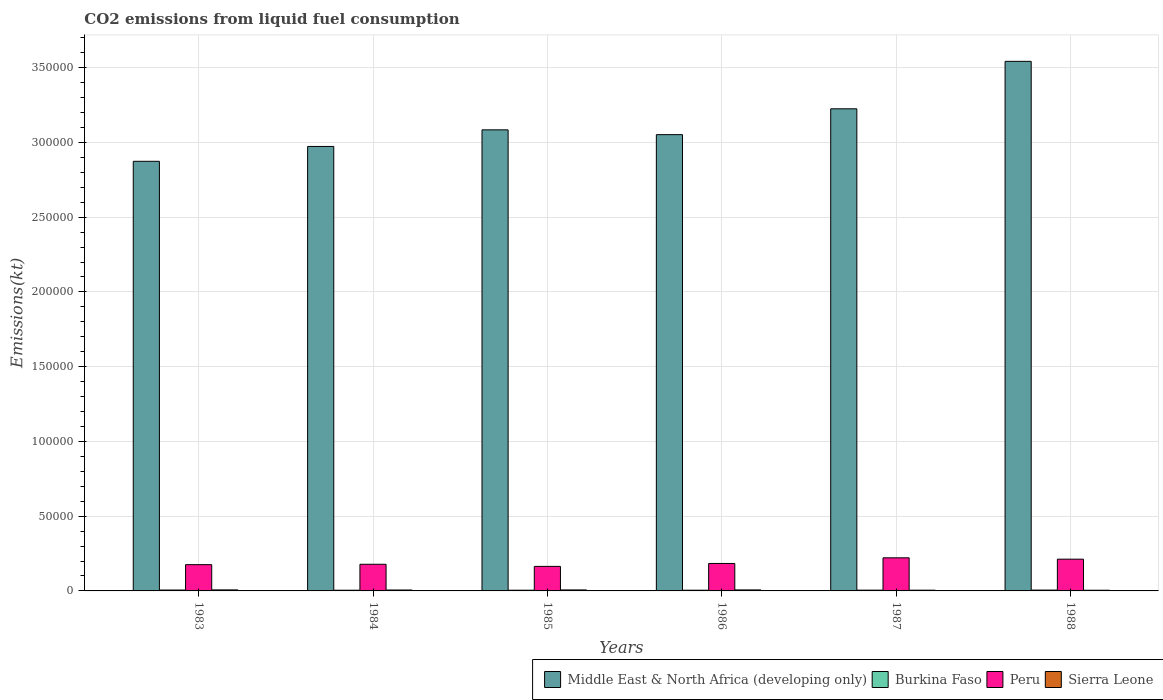Are the number of bars per tick equal to the number of legend labels?
Your answer should be compact. Yes. How many bars are there on the 3rd tick from the left?
Provide a short and direct response. 4. How many bars are there on the 1st tick from the right?
Ensure brevity in your answer.  4. In how many cases, is the number of bars for a given year not equal to the number of legend labels?
Keep it short and to the point. 0. What is the amount of CO2 emitted in Sierra Leone in 1985?
Make the answer very short. 663.73. Across all years, what is the maximum amount of CO2 emitted in Middle East & North Africa (developing only)?
Make the answer very short. 3.54e+05. Across all years, what is the minimum amount of CO2 emitted in Peru?
Your answer should be compact. 1.64e+04. What is the total amount of CO2 emitted in Sierra Leone in the graph?
Keep it short and to the point. 3600.99. What is the difference between the amount of CO2 emitted in Burkina Faso in 1985 and that in 1988?
Offer a very short reply. -77.01. What is the difference between the amount of CO2 emitted in Peru in 1988 and the amount of CO2 emitted in Middle East & North Africa (developing only) in 1983?
Provide a short and direct response. -2.66e+05. What is the average amount of CO2 emitted in Sierra Leone per year?
Give a very brief answer. 600.17. In the year 1985, what is the difference between the amount of CO2 emitted in Burkina Faso and amount of CO2 emitted in Middle East & North Africa (developing only)?
Ensure brevity in your answer.  -3.08e+05. What is the ratio of the amount of CO2 emitted in Sierra Leone in 1983 to that in 1985?
Provide a succinct answer. 1.04. Is the amount of CO2 emitted in Peru in 1983 less than that in 1984?
Keep it short and to the point. Yes. Is the difference between the amount of CO2 emitted in Burkina Faso in 1984 and 1987 greater than the difference between the amount of CO2 emitted in Middle East & North Africa (developing only) in 1984 and 1987?
Provide a succinct answer. Yes. What is the difference between the highest and the second highest amount of CO2 emitted in Burkina Faso?
Provide a short and direct response. 40.34. What is the difference between the highest and the lowest amount of CO2 emitted in Peru?
Offer a terse response. 5724.19. Is the sum of the amount of CO2 emitted in Middle East & North Africa (developing only) in 1986 and 1988 greater than the maximum amount of CO2 emitted in Sierra Leone across all years?
Your response must be concise. Yes. What does the 2nd bar from the left in 1988 represents?
Give a very brief answer. Burkina Faso. What does the 4th bar from the right in 1985 represents?
Offer a terse response. Middle East & North Africa (developing only). Is it the case that in every year, the sum of the amount of CO2 emitted in Peru and amount of CO2 emitted in Middle East & North Africa (developing only) is greater than the amount of CO2 emitted in Burkina Faso?
Provide a short and direct response. Yes. Are the values on the major ticks of Y-axis written in scientific E-notation?
Your answer should be very brief. No. What is the title of the graph?
Offer a terse response. CO2 emissions from liquid fuel consumption. Does "St. Vincent and the Grenadines" appear as one of the legend labels in the graph?
Offer a terse response. No. What is the label or title of the X-axis?
Your response must be concise. Years. What is the label or title of the Y-axis?
Provide a short and direct response. Emissions(kt). What is the Emissions(kt) of Middle East & North Africa (developing only) in 1983?
Give a very brief answer. 2.87e+05. What is the Emissions(kt) in Burkina Faso in 1983?
Make the answer very short. 594.05. What is the Emissions(kt) in Peru in 1983?
Provide a succinct answer. 1.76e+04. What is the Emissions(kt) in Sierra Leone in 1983?
Keep it short and to the point. 689.4. What is the Emissions(kt) in Middle East & North Africa (developing only) in 1984?
Keep it short and to the point. 2.97e+05. What is the Emissions(kt) in Burkina Faso in 1984?
Offer a very short reply. 465.71. What is the Emissions(kt) in Peru in 1984?
Keep it short and to the point. 1.78e+04. What is the Emissions(kt) in Sierra Leone in 1984?
Ensure brevity in your answer.  616.06. What is the Emissions(kt) in Middle East & North Africa (developing only) in 1985?
Ensure brevity in your answer.  3.08e+05. What is the Emissions(kt) of Burkina Faso in 1985?
Provide a succinct answer. 476.71. What is the Emissions(kt) of Peru in 1985?
Your answer should be very brief. 1.64e+04. What is the Emissions(kt) of Sierra Leone in 1985?
Make the answer very short. 663.73. What is the Emissions(kt) in Middle East & North Africa (developing only) in 1986?
Ensure brevity in your answer.  3.05e+05. What is the Emissions(kt) in Burkina Faso in 1986?
Offer a terse response. 480.38. What is the Emissions(kt) of Peru in 1986?
Ensure brevity in your answer.  1.84e+04. What is the Emissions(kt) in Sierra Leone in 1986?
Provide a succinct answer. 674.73. What is the Emissions(kt) in Middle East & North Africa (developing only) in 1987?
Keep it short and to the point. 3.22e+05. What is the Emissions(kt) of Burkina Faso in 1987?
Provide a short and direct response. 517.05. What is the Emissions(kt) of Peru in 1987?
Your answer should be compact. 2.21e+04. What is the Emissions(kt) in Sierra Leone in 1987?
Make the answer very short. 498.71. What is the Emissions(kt) in Middle East & North Africa (developing only) in 1988?
Give a very brief answer. 3.54e+05. What is the Emissions(kt) of Burkina Faso in 1988?
Your answer should be compact. 553.72. What is the Emissions(kt) of Peru in 1988?
Make the answer very short. 2.12e+04. What is the Emissions(kt) of Sierra Leone in 1988?
Offer a terse response. 458.38. Across all years, what is the maximum Emissions(kt) in Middle East & North Africa (developing only)?
Your answer should be very brief. 3.54e+05. Across all years, what is the maximum Emissions(kt) in Burkina Faso?
Give a very brief answer. 594.05. Across all years, what is the maximum Emissions(kt) of Peru?
Keep it short and to the point. 2.21e+04. Across all years, what is the maximum Emissions(kt) of Sierra Leone?
Give a very brief answer. 689.4. Across all years, what is the minimum Emissions(kt) of Middle East & North Africa (developing only)?
Your answer should be very brief. 2.87e+05. Across all years, what is the minimum Emissions(kt) of Burkina Faso?
Give a very brief answer. 465.71. Across all years, what is the minimum Emissions(kt) in Peru?
Give a very brief answer. 1.64e+04. Across all years, what is the minimum Emissions(kt) in Sierra Leone?
Your response must be concise. 458.38. What is the total Emissions(kt) of Middle East & North Africa (developing only) in the graph?
Give a very brief answer. 1.88e+06. What is the total Emissions(kt) of Burkina Faso in the graph?
Keep it short and to the point. 3087.61. What is the total Emissions(kt) of Peru in the graph?
Keep it short and to the point. 1.14e+05. What is the total Emissions(kt) of Sierra Leone in the graph?
Give a very brief answer. 3600.99. What is the difference between the Emissions(kt) in Middle East & North Africa (developing only) in 1983 and that in 1984?
Your response must be concise. -9935.62. What is the difference between the Emissions(kt) of Burkina Faso in 1983 and that in 1984?
Your answer should be compact. 128.34. What is the difference between the Emissions(kt) in Peru in 1983 and that in 1984?
Provide a short and direct response. -245.69. What is the difference between the Emissions(kt) in Sierra Leone in 1983 and that in 1984?
Provide a succinct answer. 73.34. What is the difference between the Emissions(kt) of Middle East & North Africa (developing only) in 1983 and that in 1985?
Your response must be concise. -2.10e+04. What is the difference between the Emissions(kt) in Burkina Faso in 1983 and that in 1985?
Offer a terse response. 117.34. What is the difference between the Emissions(kt) of Peru in 1983 and that in 1985?
Ensure brevity in your answer.  1162.44. What is the difference between the Emissions(kt) of Sierra Leone in 1983 and that in 1985?
Offer a terse response. 25.67. What is the difference between the Emissions(kt) in Middle East & North Africa (developing only) in 1983 and that in 1986?
Offer a terse response. -1.78e+04. What is the difference between the Emissions(kt) in Burkina Faso in 1983 and that in 1986?
Offer a terse response. 113.68. What is the difference between the Emissions(kt) in Peru in 1983 and that in 1986?
Your answer should be very brief. -788.4. What is the difference between the Emissions(kt) of Sierra Leone in 1983 and that in 1986?
Ensure brevity in your answer.  14.67. What is the difference between the Emissions(kt) of Middle East & North Africa (developing only) in 1983 and that in 1987?
Keep it short and to the point. -3.51e+04. What is the difference between the Emissions(kt) in Burkina Faso in 1983 and that in 1987?
Make the answer very short. 77.01. What is the difference between the Emissions(kt) in Peru in 1983 and that in 1987?
Provide a succinct answer. -4561.75. What is the difference between the Emissions(kt) of Sierra Leone in 1983 and that in 1987?
Make the answer very short. 190.68. What is the difference between the Emissions(kt) of Middle East & North Africa (developing only) in 1983 and that in 1988?
Offer a terse response. -6.69e+04. What is the difference between the Emissions(kt) of Burkina Faso in 1983 and that in 1988?
Make the answer very short. 40.34. What is the difference between the Emissions(kt) in Peru in 1983 and that in 1988?
Your answer should be very brief. -3663.33. What is the difference between the Emissions(kt) in Sierra Leone in 1983 and that in 1988?
Provide a succinct answer. 231.02. What is the difference between the Emissions(kt) in Middle East & North Africa (developing only) in 1984 and that in 1985?
Your answer should be very brief. -1.11e+04. What is the difference between the Emissions(kt) of Burkina Faso in 1984 and that in 1985?
Make the answer very short. -11. What is the difference between the Emissions(kt) in Peru in 1984 and that in 1985?
Ensure brevity in your answer.  1408.13. What is the difference between the Emissions(kt) in Sierra Leone in 1984 and that in 1985?
Your answer should be compact. -47.67. What is the difference between the Emissions(kt) in Middle East & North Africa (developing only) in 1984 and that in 1986?
Offer a terse response. -7894.91. What is the difference between the Emissions(kt) in Burkina Faso in 1984 and that in 1986?
Provide a short and direct response. -14.67. What is the difference between the Emissions(kt) in Peru in 1984 and that in 1986?
Ensure brevity in your answer.  -542.72. What is the difference between the Emissions(kt) in Sierra Leone in 1984 and that in 1986?
Your answer should be compact. -58.67. What is the difference between the Emissions(kt) in Middle East & North Africa (developing only) in 1984 and that in 1987?
Offer a very short reply. -2.52e+04. What is the difference between the Emissions(kt) in Burkina Faso in 1984 and that in 1987?
Ensure brevity in your answer.  -51.34. What is the difference between the Emissions(kt) in Peru in 1984 and that in 1987?
Make the answer very short. -4316.06. What is the difference between the Emissions(kt) in Sierra Leone in 1984 and that in 1987?
Your answer should be compact. 117.34. What is the difference between the Emissions(kt) of Middle East & North Africa (developing only) in 1984 and that in 1988?
Provide a short and direct response. -5.69e+04. What is the difference between the Emissions(kt) of Burkina Faso in 1984 and that in 1988?
Your answer should be compact. -88.01. What is the difference between the Emissions(kt) of Peru in 1984 and that in 1988?
Make the answer very short. -3417.64. What is the difference between the Emissions(kt) of Sierra Leone in 1984 and that in 1988?
Your response must be concise. 157.68. What is the difference between the Emissions(kt) of Middle East & North Africa (developing only) in 1985 and that in 1986?
Provide a succinct answer. 3207.88. What is the difference between the Emissions(kt) of Burkina Faso in 1985 and that in 1986?
Provide a short and direct response. -3.67. What is the difference between the Emissions(kt) of Peru in 1985 and that in 1986?
Give a very brief answer. -1950.84. What is the difference between the Emissions(kt) of Sierra Leone in 1985 and that in 1986?
Offer a terse response. -11. What is the difference between the Emissions(kt) of Middle East & North Africa (developing only) in 1985 and that in 1987?
Provide a succinct answer. -1.41e+04. What is the difference between the Emissions(kt) of Burkina Faso in 1985 and that in 1987?
Give a very brief answer. -40.34. What is the difference between the Emissions(kt) of Peru in 1985 and that in 1987?
Make the answer very short. -5724.19. What is the difference between the Emissions(kt) in Sierra Leone in 1985 and that in 1987?
Your answer should be very brief. 165.01. What is the difference between the Emissions(kt) in Middle East & North Africa (developing only) in 1985 and that in 1988?
Offer a very short reply. -4.58e+04. What is the difference between the Emissions(kt) in Burkina Faso in 1985 and that in 1988?
Ensure brevity in your answer.  -77.01. What is the difference between the Emissions(kt) of Peru in 1985 and that in 1988?
Your answer should be very brief. -4825.77. What is the difference between the Emissions(kt) in Sierra Leone in 1985 and that in 1988?
Offer a very short reply. 205.35. What is the difference between the Emissions(kt) of Middle East & North Africa (developing only) in 1986 and that in 1987?
Ensure brevity in your answer.  -1.73e+04. What is the difference between the Emissions(kt) in Burkina Faso in 1986 and that in 1987?
Your answer should be compact. -36.67. What is the difference between the Emissions(kt) of Peru in 1986 and that in 1987?
Offer a very short reply. -3773.34. What is the difference between the Emissions(kt) of Sierra Leone in 1986 and that in 1987?
Ensure brevity in your answer.  176.02. What is the difference between the Emissions(kt) of Middle East & North Africa (developing only) in 1986 and that in 1988?
Make the answer very short. -4.90e+04. What is the difference between the Emissions(kt) of Burkina Faso in 1986 and that in 1988?
Offer a terse response. -73.34. What is the difference between the Emissions(kt) of Peru in 1986 and that in 1988?
Your answer should be compact. -2874.93. What is the difference between the Emissions(kt) of Sierra Leone in 1986 and that in 1988?
Keep it short and to the point. 216.35. What is the difference between the Emissions(kt) of Middle East & North Africa (developing only) in 1987 and that in 1988?
Make the answer very short. -3.17e+04. What is the difference between the Emissions(kt) in Burkina Faso in 1987 and that in 1988?
Your response must be concise. -36.67. What is the difference between the Emissions(kt) of Peru in 1987 and that in 1988?
Make the answer very short. 898.41. What is the difference between the Emissions(kt) of Sierra Leone in 1987 and that in 1988?
Offer a terse response. 40.34. What is the difference between the Emissions(kt) in Middle East & North Africa (developing only) in 1983 and the Emissions(kt) in Burkina Faso in 1984?
Your response must be concise. 2.87e+05. What is the difference between the Emissions(kt) of Middle East & North Africa (developing only) in 1983 and the Emissions(kt) of Peru in 1984?
Provide a succinct answer. 2.70e+05. What is the difference between the Emissions(kt) of Middle East & North Africa (developing only) in 1983 and the Emissions(kt) of Sierra Leone in 1984?
Make the answer very short. 2.87e+05. What is the difference between the Emissions(kt) in Burkina Faso in 1983 and the Emissions(kt) in Peru in 1984?
Provide a succinct answer. -1.72e+04. What is the difference between the Emissions(kt) of Burkina Faso in 1983 and the Emissions(kt) of Sierra Leone in 1984?
Your answer should be compact. -22. What is the difference between the Emissions(kt) of Peru in 1983 and the Emissions(kt) of Sierra Leone in 1984?
Provide a succinct answer. 1.70e+04. What is the difference between the Emissions(kt) of Middle East & North Africa (developing only) in 1983 and the Emissions(kt) of Burkina Faso in 1985?
Offer a very short reply. 2.87e+05. What is the difference between the Emissions(kt) in Middle East & North Africa (developing only) in 1983 and the Emissions(kt) in Peru in 1985?
Your answer should be very brief. 2.71e+05. What is the difference between the Emissions(kt) in Middle East & North Africa (developing only) in 1983 and the Emissions(kt) in Sierra Leone in 1985?
Keep it short and to the point. 2.87e+05. What is the difference between the Emissions(kt) of Burkina Faso in 1983 and the Emissions(kt) of Peru in 1985?
Provide a succinct answer. -1.58e+04. What is the difference between the Emissions(kt) of Burkina Faso in 1983 and the Emissions(kt) of Sierra Leone in 1985?
Your response must be concise. -69.67. What is the difference between the Emissions(kt) in Peru in 1983 and the Emissions(kt) in Sierra Leone in 1985?
Provide a short and direct response. 1.69e+04. What is the difference between the Emissions(kt) of Middle East & North Africa (developing only) in 1983 and the Emissions(kt) of Burkina Faso in 1986?
Provide a short and direct response. 2.87e+05. What is the difference between the Emissions(kt) in Middle East & North Africa (developing only) in 1983 and the Emissions(kt) in Peru in 1986?
Provide a succinct answer. 2.69e+05. What is the difference between the Emissions(kt) of Middle East & North Africa (developing only) in 1983 and the Emissions(kt) of Sierra Leone in 1986?
Provide a short and direct response. 2.87e+05. What is the difference between the Emissions(kt) of Burkina Faso in 1983 and the Emissions(kt) of Peru in 1986?
Ensure brevity in your answer.  -1.78e+04. What is the difference between the Emissions(kt) of Burkina Faso in 1983 and the Emissions(kt) of Sierra Leone in 1986?
Your response must be concise. -80.67. What is the difference between the Emissions(kt) in Peru in 1983 and the Emissions(kt) in Sierra Leone in 1986?
Your answer should be compact. 1.69e+04. What is the difference between the Emissions(kt) in Middle East & North Africa (developing only) in 1983 and the Emissions(kt) in Burkina Faso in 1987?
Offer a terse response. 2.87e+05. What is the difference between the Emissions(kt) of Middle East & North Africa (developing only) in 1983 and the Emissions(kt) of Peru in 1987?
Make the answer very short. 2.65e+05. What is the difference between the Emissions(kt) in Middle East & North Africa (developing only) in 1983 and the Emissions(kt) in Sierra Leone in 1987?
Give a very brief answer. 2.87e+05. What is the difference between the Emissions(kt) in Burkina Faso in 1983 and the Emissions(kt) in Peru in 1987?
Ensure brevity in your answer.  -2.15e+04. What is the difference between the Emissions(kt) in Burkina Faso in 1983 and the Emissions(kt) in Sierra Leone in 1987?
Keep it short and to the point. 95.34. What is the difference between the Emissions(kt) of Peru in 1983 and the Emissions(kt) of Sierra Leone in 1987?
Offer a very short reply. 1.71e+04. What is the difference between the Emissions(kt) in Middle East & North Africa (developing only) in 1983 and the Emissions(kt) in Burkina Faso in 1988?
Offer a terse response. 2.87e+05. What is the difference between the Emissions(kt) in Middle East & North Africa (developing only) in 1983 and the Emissions(kt) in Peru in 1988?
Provide a succinct answer. 2.66e+05. What is the difference between the Emissions(kt) in Middle East & North Africa (developing only) in 1983 and the Emissions(kt) in Sierra Leone in 1988?
Offer a very short reply. 2.87e+05. What is the difference between the Emissions(kt) in Burkina Faso in 1983 and the Emissions(kt) in Peru in 1988?
Provide a short and direct response. -2.06e+04. What is the difference between the Emissions(kt) of Burkina Faso in 1983 and the Emissions(kt) of Sierra Leone in 1988?
Offer a very short reply. 135.68. What is the difference between the Emissions(kt) of Peru in 1983 and the Emissions(kt) of Sierra Leone in 1988?
Provide a succinct answer. 1.71e+04. What is the difference between the Emissions(kt) in Middle East & North Africa (developing only) in 1984 and the Emissions(kt) in Burkina Faso in 1985?
Give a very brief answer. 2.97e+05. What is the difference between the Emissions(kt) of Middle East & North Africa (developing only) in 1984 and the Emissions(kt) of Peru in 1985?
Provide a short and direct response. 2.81e+05. What is the difference between the Emissions(kt) in Middle East & North Africa (developing only) in 1984 and the Emissions(kt) in Sierra Leone in 1985?
Your answer should be very brief. 2.97e+05. What is the difference between the Emissions(kt) of Burkina Faso in 1984 and the Emissions(kt) of Peru in 1985?
Provide a succinct answer. -1.59e+04. What is the difference between the Emissions(kt) of Burkina Faso in 1984 and the Emissions(kt) of Sierra Leone in 1985?
Give a very brief answer. -198.02. What is the difference between the Emissions(kt) in Peru in 1984 and the Emissions(kt) in Sierra Leone in 1985?
Ensure brevity in your answer.  1.72e+04. What is the difference between the Emissions(kt) in Middle East & North Africa (developing only) in 1984 and the Emissions(kt) in Burkina Faso in 1986?
Provide a succinct answer. 2.97e+05. What is the difference between the Emissions(kt) in Middle East & North Africa (developing only) in 1984 and the Emissions(kt) in Peru in 1986?
Provide a succinct answer. 2.79e+05. What is the difference between the Emissions(kt) of Middle East & North Africa (developing only) in 1984 and the Emissions(kt) of Sierra Leone in 1986?
Provide a short and direct response. 2.97e+05. What is the difference between the Emissions(kt) of Burkina Faso in 1984 and the Emissions(kt) of Peru in 1986?
Offer a very short reply. -1.79e+04. What is the difference between the Emissions(kt) in Burkina Faso in 1984 and the Emissions(kt) in Sierra Leone in 1986?
Provide a short and direct response. -209.02. What is the difference between the Emissions(kt) in Peru in 1984 and the Emissions(kt) in Sierra Leone in 1986?
Offer a terse response. 1.71e+04. What is the difference between the Emissions(kt) of Middle East & North Africa (developing only) in 1984 and the Emissions(kt) of Burkina Faso in 1987?
Make the answer very short. 2.97e+05. What is the difference between the Emissions(kt) of Middle East & North Africa (developing only) in 1984 and the Emissions(kt) of Peru in 1987?
Make the answer very short. 2.75e+05. What is the difference between the Emissions(kt) of Middle East & North Africa (developing only) in 1984 and the Emissions(kt) of Sierra Leone in 1987?
Offer a very short reply. 2.97e+05. What is the difference between the Emissions(kt) of Burkina Faso in 1984 and the Emissions(kt) of Peru in 1987?
Your answer should be compact. -2.17e+04. What is the difference between the Emissions(kt) of Burkina Faso in 1984 and the Emissions(kt) of Sierra Leone in 1987?
Offer a terse response. -33. What is the difference between the Emissions(kt) of Peru in 1984 and the Emissions(kt) of Sierra Leone in 1987?
Provide a succinct answer. 1.73e+04. What is the difference between the Emissions(kt) of Middle East & North Africa (developing only) in 1984 and the Emissions(kt) of Burkina Faso in 1988?
Offer a terse response. 2.97e+05. What is the difference between the Emissions(kt) of Middle East & North Africa (developing only) in 1984 and the Emissions(kt) of Peru in 1988?
Your answer should be very brief. 2.76e+05. What is the difference between the Emissions(kt) in Middle East & North Africa (developing only) in 1984 and the Emissions(kt) in Sierra Leone in 1988?
Your answer should be compact. 2.97e+05. What is the difference between the Emissions(kt) of Burkina Faso in 1984 and the Emissions(kt) of Peru in 1988?
Make the answer very short. -2.08e+04. What is the difference between the Emissions(kt) in Burkina Faso in 1984 and the Emissions(kt) in Sierra Leone in 1988?
Provide a succinct answer. 7.33. What is the difference between the Emissions(kt) of Peru in 1984 and the Emissions(kt) of Sierra Leone in 1988?
Give a very brief answer. 1.74e+04. What is the difference between the Emissions(kt) of Middle East & North Africa (developing only) in 1985 and the Emissions(kt) of Burkina Faso in 1986?
Keep it short and to the point. 3.08e+05. What is the difference between the Emissions(kt) of Middle East & North Africa (developing only) in 1985 and the Emissions(kt) of Peru in 1986?
Your answer should be very brief. 2.90e+05. What is the difference between the Emissions(kt) of Middle East & North Africa (developing only) in 1985 and the Emissions(kt) of Sierra Leone in 1986?
Your answer should be compact. 3.08e+05. What is the difference between the Emissions(kt) in Burkina Faso in 1985 and the Emissions(kt) in Peru in 1986?
Ensure brevity in your answer.  -1.79e+04. What is the difference between the Emissions(kt) in Burkina Faso in 1985 and the Emissions(kt) in Sierra Leone in 1986?
Ensure brevity in your answer.  -198.02. What is the difference between the Emissions(kt) of Peru in 1985 and the Emissions(kt) of Sierra Leone in 1986?
Your answer should be compact. 1.57e+04. What is the difference between the Emissions(kt) in Middle East & North Africa (developing only) in 1985 and the Emissions(kt) in Burkina Faso in 1987?
Your answer should be very brief. 3.08e+05. What is the difference between the Emissions(kt) in Middle East & North Africa (developing only) in 1985 and the Emissions(kt) in Peru in 1987?
Provide a short and direct response. 2.86e+05. What is the difference between the Emissions(kt) of Middle East & North Africa (developing only) in 1985 and the Emissions(kt) of Sierra Leone in 1987?
Keep it short and to the point. 3.08e+05. What is the difference between the Emissions(kt) in Burkina Faso in 1985 and the Emissions(kt) in Peru in 1987?
Provide a succinct answer. -2.17e+04. What is the difference between the Emissions(kt) of Burkina Faso in 1985 and the Emissions(kt) of Sierra Leone in 1987?
Provide a succinct answer. -22. What is the difference between the Emissions(kt) in Peru in 1985 and the Emissions(kt) in Sierra Leone in 1987?
Offer a terse response. 1.59e+04. What is the difference between the Emissions(kt) of Middle East & North Africa (developing only) in 1985 and the Emissions(kt) of Burkina Faso in 1988?
Make the answer very short. 3.08e+05. What is the difference between the Emissions(kt) in Middle East & North Africa (developing only) in 1985 and the Emissions(kt) in Peru in 1988?
Ensure brevity in your answer.  2.87e+05. What is the difference between the Emissions(kt) of Middle East & North Africa (developing only) in 1985 and the Emissions(kt) of Sierra Leone in 1988?
Give a very brief answer. 3.08e+05. What is the difference between the Emissions(kt) of Burkina Faso in 1985 and the Emissions(kt) of Peru in 1988?
Offer a very short reply. -2.08e+04. What is the difference between the Emissions(kt) of Burkina Faso in 1985 and the Emissions(kt) of Sierra Leone in 1988?
Ensure brevity in your answer.  18.34. What is the difference between the Emissions(kt) in Peru in 1985 and the Emissions(kt) in Sierra Leone in 1988?
Your response must be concise. 1.60e+04. What is the difference between the Emissions(kt) of Middle East & North Africa (developing only) in 1986 and the Emissions(kt) of Burkina Faso in 1987?
Offer a very short reply. 3.05e+05. What is the difference between the Emissions(kt) in Middle East & North Africa (developing only) in 1986 and the Emissions(kt) in Peru in 1987?
Ensure brevity in your answer.  2.83e+05. What is the difference between the Emissions(kt) of Middle East & North Africa (developing only) in 1986 and the Emissions(kt) of Sierra Leone in 1987?
Give a very brief answer. 3.05e+05. What is the difference between the Emissions(kt) of Burkina Faso in 1986 and the Emissions(kt) of Peru in 1987?
Your response must be concise. -2.17e+04. What is the difference between the Emissions(kt) of Burkina Faso in 1986 and the Emissions(kt) of Sierra Leone in 1987?
Offer a terse response. -18.34. What is the difference between the Emissions(kt) in Peru in 1986 and the Emissions(kt) in Sierra Leone in 1987?
Your answer should be compact. 1.79e+04. What is the difference between the Emissions(kt) of Middle East & North Africa (developing only) in 1986 and the Emissions(kt) of Burkina Faso in 1988?
Provide a short and direct response. 3.05e+05. What is the difference between the Emissions(kt) in Middle East & North Africa (developing only) in 1986 and the Emissions(kt) in Peru in 1988?
Your response must be concise. 2.84e+05. What is the difference between the Emissions(kt) of Middle East & North Africa (developing only) in 1986 and the Emissions(kt) of Sierra Leone in 1988?
Offer a very short reply. 3.05e+05. What is the difference between the Emissions(kt) in Burkina Faso in 1986 and the Emissions(kt) in Peru in 1988?
Provide a succinct answer. -2.08e+04. What is the difference between the Emissions(kt) of Burkina Faso in 1986 and the Emissions(kt) of Sierra Leone in 1988?
Provide a short and direct response. 22. What is the difference between the Emissions(kt) of Peru in 1986 and the Emissions(kt) of Sierra Leone in 1988?
Ensure brevity in your answer.  1.79e+04. What is the difference between the Emissions(kt) in Middle East & North Africa (developing only) in 1987 and the Emissions(kt) in Burkina Faso in 1988?
Offer a very short reply. 3.22e+05. What is the difference between the Emissions(kt) of Middle East & North Africa (developing only) in 1987 and the Emissions(kt) of Peru in 1988?
Offer a terse response. 3.01e+05. What is the difference between the Emissions(kt) in Middle East & North Africa (developing only) in 1987 and the Emissions(kt) in Sierra Leone in 1988?
Give a very brief answer. 3.22e+05. What is the difference between the Emissions(kt) in Burkina Faso in 1987 and the Emissions(kt) in Peru in 1988?
Make the answer very short. -2.07e+04. What is the difference between the Emissions(kt) of Burkina Faso in 1987 and the Emissions(kt) of Sierra Leone in 1988?
Provide a short and direct response. 58.67. What is the difference between the Emissions(kt) of Peru in 1987 and the Emissions(kt) of Sierra Leone in 1988?
Your response must be concise. 2.17e+04. What is the average Emissions(kt) of Middle East & North Africa (developing only) per year?
Provide a succinct answer. 3.13e+05. What is the average Emissions(kt) in Burkina Faso per year?
Give a very brief answer. 514.6. What is the average Emissions(kt) of Peru per year?
Your response must be concise. 1.89e+04. What is the average Emissions(kt) of Sierra Leone per year?
Provide a short and direct response. 600.17. In the year 1983, what is the difference between the Emissions(kt) in Middle East & North Africa (developing only) and Emissions(kt) in Burkina Faso?
Keep it short and to the point. 2.87e+05. In the year 1983, what is the difference between the Emissions(kt) of Middle East & North Africa (developing only) and Emissions(kt) of Peru?
Make the answer very short. 2.70e+05. In the year 1983, what is the difference between the Emissions(kt) in Middle East & North Africa (developing only) and Emissions(kt) in Sierra Leone?
Provide a short and direct response. 2.87e+05. In the year 1983, what is the difference between the Emissions(kt) in Burkina Faso and Emissions(kt) in Peru?
Provide a succinct answer. -1.70e+04. In the year 1983, what is the difference between the Emissions(kt) in Burkina Faso and Emissions(kt) in Sierra Leone?
Provide a succinct answer. -95.34. In the year 1983, what is the difference between the Emissions(kt) of Peru and Emissions(kt) of Sierra Leone?
Your answer should be very brief. 1.69e+04. In the year 1984, what is the difference between the Emissions(kt) of Middle East & North Africa (developing only) and Emissions(kt) of Burkina Faso?
Provide a short and direct response. 2.97e+05. In the year 1984, what is the difference between the Emissions(kt) in Middle East & North Africa (developing only) and Emissions(kt) in Peru?
Ensure brevity in your answer.  2.79e+05. In the year 1984, what is the difference between the Emissions(kt) in Middle East & North Africa (developing only) and Emissions(kt) in Sierra Leone?
Ensure brevity in your answer.  2.97e+05. In the year 1984, what is the difference between the Emissions(kt) in Burkina Faso and Emissions(kt) in Peru?
Your answer should be very brief. -1.74e+04. In the year 1984, what is the difference between the Emissions(kt) of Burkina Faso and Emissions(kt) of Sierra Leone?
Provide a short and direct response. -150.35. In the year 1984, what is the difference between the Emissions(kt) of Peru and Emissions(kt) of Sierra Leone?
Your answer should be compact. 1.72e+04. In the year 1985, what is the difference between the Emissions(kt) in Middle East & North Africa (developing only) and Emissions(kt) in Burkina Faso?
Give a very brief answer. 3.08e+05. In the year 1985, what is the difference between the Emissions(kt) in Middle East & North Africa (developing only) and Emissions(kt) in Peru?
Ensure brevity in your answer.  2.92e+05. In the year 1985, what is the difference between the Emissions(kt) of Middle East & North Africa (developing only) and Emissions(kt) of Sierra Leone?
Ensure brevity in your answer.  3.08e+05. In the year 1985, what is the difference between the Emissions(kt) of Burkina Faso and Emissions(kt) of Peru?
Your answer should be compact. -1.59e+04. In the year 1985, what is the difference between the Emissions(kt) of Burkina Faso and Emissions(kt) of Sierra Leone?
Provide a short and direct response. -187.02. In the year 1985, what is the difference between the Emissions(kt) of Peru and Emissions(kt) of Sierra Leone?
Your answer should be very brief. 1.57e+04. In the year 1986, what is the difference between the Emissions(kt) of Middle East & North Africa (developing only) and Emissions(kt) of Burkina Faso?
Make the answer very short. 3.05e+05. In the year 1986, what is the difference between the Emissions(kt) of Middle East & North Africa (developing only) and Emissions(kt) of Peru?
Offer a very short reply. 2.87e+05. In the year 1986, what is the difference between the Emissions(kt) of Middle East & North Africa (developing only) and Emissions(kt) of Sierra Leone?
Offer a terse response. 3.05e+05. In the year 1986, what is the difference between the Emissions(kt) of Burkina Faso and Emissions(kt) of Peru?
Your answer should be very brief. -1.79e+04. In the year 1986, what is the difference between the Emissions(kt) in Burkina Faso and Emissions(kt) in Sierra Leone?
Your response must be concise. -194.35. In the year 1986, what is the difference between the Emissions(kt) in Peru and Emissions(kt) in Sierra Leone?
Offer a very short reply. 1.77e+04. In the year 1987, what is the difference between the Emissions(kt) in Middle East & North Africa (developing only) and Emissions(kt) in Burkina Faso?
Your answer should be very brief. 3.22e+05. In the year 1987, what is the difference between the Emissions(kt) in Middle East & North Africa (developing only) and Emissions(kt) in Peru?
Offer a very short reply. 3.00e+05. In the year 1987, what is the difference between the Emissions(kt) in Middle East & North Africa (developing only) and Emissions(kt) in Sierra Leone?
Offer a very short reply. 3.22e+05. In the year 1987, what is the difference between the Emissions(kt) of Burkina Faso and Emissions(kt) of Peru?
Your answer should be very brief. -2.16e+04. In the year 1987, what is the difference between the Emissions(kt) of Burkina Faso and Emissions(kt) of Sierra Leone?
Provide a short and direct response. 18.34. In the year 1987, what is the difference between the Emissions(kt) of Peru and Emissions(kt) of Sierra Leone?
Provide a short and direct response. 2.16e+04. In the year 1988, what is the difference between the Emissions(kt) of Middle East & North Africa (developing only) and Emissions(kt) of Burkina Faso?
Provide a succinct answer. 3.54e+05. In the year 1988, what is the difference between the Emissions(kt) in Middle East & North Africa (developing only) and Emissions(kt) in Peru?
Provide a short and direct response. 3.33e+05. In the year 1988, what is the difference between the Emissions(kt) of Middle East & North Africa (developing only) and Emissions(kt) of Sierra Leone?
Offer a very short reply. 3.54e+05. In the year 1988, what is the difference between the Emissions(kt) in Burkina Faso and Emissions(kt) in Peru?
Offer a terse response. -2.07e+04. In the year 1988, what is the difference between the Emissions(kt) of Burkina Faso and Emissions(kt) of Sierra Leone?
Your answer should be very brief. 95.34. In the year 1988, what is the difference between the Emissions(kt) of Peru and Emissions(kt) of Sierra Leone?
Give a very brief answer. 2.08e+04. What is the ratio of the Emissions(kt) in Middle East & North Africa (developing only) in 1983 to that in 1984?
Your response must be concise. 0.97. What is the ratio of the Emissions(kt) of Burkina Faso in 1983 to that in 1984?
Provide a short and direct response. 1.28. What is the ratio of the Emissions(kt) in Peru in 1983 to that in 1984?
Offer a very short reply. 0.99. What is the ratio of the Emissions(kt) of Sierra Leone in 1983 to that in 1984?
Your answer should be compact. 1.12. What is the ratio of the Emissions(kt) of Middle East & North Africa (developing only) in 1983 to that in 1985?
Your response must be concise. 0.93. What is the ratio of the Emissions(kt) in Burkina Faso in 1983 to that in 1985?
Your response must be concise. 1.25. What is the ratio of the Emissions(kt) in Peru in 1983 to that in 1985?
Give a very brief answer. 1.07. What is the ratio of the Emissions(kt) of Sierra Leone in 1983 to that in 1985?
Offer a terse response. 1.04. What is the ratio of the Emissions(kt) in Middle East & North Africa (developing only) in 1983 to that in 1986?
Ensure brevity in your answer.  0.94. What is the ratio of the Emissions(kt) of Burkina Faso in 1983 to that in 1986?
Give a very brief answer. 1.24. What is the ratio of the Emissions(kt) in Peru in 1983 to that in 1986?
Provide a short and direct response. 0.96. What is the ratio of the Emissions(kt) in Sierra Leone in 1983 to that in 1986?
Your answer should be compact. 1.02. What is the ratio of the Emissions(kt) of Middle East & North Africa (developing only) in 1983 to that in 1987?
Provide a succinct answer. 0.89. What is the ratio of the Emissions(kt) of Burkina Faso in 1983 to that in 1987?
Offer a terse response. 1.15. What is the ratio of the Emissions(kt) of Peru in 1983 to that in 1987?
Offer a very short reply. 0.79. What is the ratio of the Emissions(kt) of Sierra Leone in 1983 to that in 1987?
Your answer should be very brief. 1.38. What is the ratio of the Emissions(kt) in Middle East & North Africa (developing only) in 1983 to that in 1988?
Give a very brief answer. 0.81. What is the ratio of the Emissions(kt) of Burkina Faso in 1983 to that in 1988?
Keep it short and to the point. 1.07. What is the ratio of the Emissions(kt) of Peru in 1983 to that in 1988?
Your answer should be very brief. 0.83. What is the ratio of the Emissions(kt) of Sierra Leone in 1983 to that in 1988?
Provide a succinct answer. 1.5. What is the ratio of the Emissions(kt) of Middle East & North Africa (developing only) in 1984 to that in 1985?
Offer a very short reply. 0.96. What is the ratio of the Emissions(kt) of Burkina Faso in 1984 to that in 1985?
Keep it short and to the point. 0.98. What is the ratio of the Emissions(kt) in Peru in 1984 to that in 1985?
Offer a terse response. 1.09. What is the ratio of the Emissions(kt) of Sierra Leone in 1984 to that in 1985?
Give a very brief answer. 0.93. What is the ratio of the Emissions(kt) of Middle East & North Africa (developing only) in 1984 to that in 1986?
Your answer should be very brief. 0.97. What is the ratio of the Emissions(kt) of Burkina Faso in 1984 to that in 1986?
Your answer should be compact. 0.97. What is the ratio of the Emissions(kt) in Peru in 1984 to that in 1986?
Offer a terse response. 0.97. What is the ratio of the Emissions(kt) of Sierra Leone in 1984 to that in 1986?
Offer a very short reply. 0.91. What is the ratio of the Emissions(kt) of Middle East & North Africa (developing only) in 1984 to that in 1987?
Your answer should be very brief. 0.92. What is the ratio of the Emissions(kt) in Burkina Faso in 1984 to that in 1987?
Offer a very short reply. 0.9. What is the ratio of the Emissions(kt) of Peru in 1984 to that in 1987?
Keep it short and to the point. 0.81. What is the ratio of the Emissions(kt) of Sierra Leone in 1984 to that in 1987?
Offer a very short reply. 1.24. What is the ratio of the Emissions(kt) of Middle East & North Africa (developing only) in 1984 to that in 1988?
Provide a succinct answer. 0.84. What is the ratio of the Emissions(kt) in Burkina Faso in 1984 to that in 1988?
Your answer should be compact. 0.84. What is the ratio of the Emissions(kt) in Peru in 1984 to that in 1988?
Keep it short and to the point. 0.84. What is the ratio of the Emissions(kt) of Sierra Leone in 1984 to that in 1988?
Provide a short and direct response. 1.34. What is the ratio of the Emissions(kt) of Middle East & North Africa (developing only) in 1985 to that in 1986?
Keep it short and to the point. 1.01. What is the ratio of the Emissions(kt) in Burkina Faso in 1985 to that in 1986?
Offer a terse response. 0.99. What is the ratio of the Emissions(kt) of Peru in 1985 to that in 1986?
Your answer should be compact. 0.89. What is the ratio of the Emissions(kt) of Sierra Leone in 1985 to that in 1986?
Keep it short and to the point. 0.98. What is the ratio of the Emissions(kt) in Middle East & North Africa (developing only) in 1985 to that in 1987?
Make the answer very short. 0.96. What is the ratio of the Emissions(kt) in Burkina Faso in 1985 to that in 1987?
Make the answer very short. 0.92. What is the ratio of the Emissions(kt) of Peru in 1985 to that in 1987?
Make the answer very short. 0.74. What is the ratio of the Emissions(kt) of Sierra Leone in 1985 to that in 1987?
Offer a terse response. 1.33. What is the ratio of the Emissions(kt) of Middle East & North Africa (developing only) in 1985 to that in 1988?
Provide a succinct answer. 0.87. What is the ratio of the Emissions(kt) of Burkina Faso in 1985 to that in 1988?
Offer a very short reply. 0.86. What is the ratio of the Emissions(kt) of Peru in 1985 to that in 1988?
Make the answer very short. 0.77. What is the ratio of the Emissions(kt) of Sierra Leone in 1985 to that in 1988?
Your answer should be very brief. 1.45. What is the ratio of the Emissions(kt) in Middle East & North Africa (developing only) in 1986 to that in 1987?
Ensure brevity in your answer.  0.95. What is the ratio of the Emissions(kt) in Burkina Faso in 1986 to that in 1987?
Your answer should be very brief. 0.93. What is the ratio of the Emissions(kt) of Peru in 1986 to that in 1987?
Make the answer very short. 0.83. What is the ratio of the Emissions(kt) of Sierra Leone in 1986 to that in 1987?
Offer a terse response. 1.35. What is the ratio of the Emissions(kt) in Middle East & North Africa (developing only) in 1986 to that in 1988?
Provide a short and direct response. 0.86. What is the ratio of the Emissions(kt) in Burkina Faso in 1986 to that in 1988?
Your answer should be compact. 0.87. What is the ratio of the Emissions(kt) of Peru in 1986 to that in 1988?
Offer a terse response. 0.86. What is the ratio of the Emissions(kt) in Sierra Leone in 1986 to that in 1988?
Make the answer very short. 1.47. What is the ratio of the Emissions(kt) of Middle East & North Africa (developing only) in 1987 to that in 1988?
Your response must be concise. 0.91. What is the ratio of the Emissions(kt) of Burkina Faso in 1987 to that in 1988?
Offer a terse response. 0.93. What is the ratio of the Emissions(kt) in Peru in 1987 to that in 1988?
Your answer should be compact. 1.04. What is the ratio of the Emissions(kt) in Sierra Leone in 1987 to that in 1988?
Keep it short and to the point. 1.09. What is the difference between the highest and the second highest Emissions(kt) of Middle East & North Africa (developing only)?
Provide a succinct answer. 3.17e+04. What is the difference between the highest and the second highest Emissions(kt) in Burkina Faso?
Your response must be concise. 40.34. What is the difference between the highest and the second highest Emissions(kt) in Peru?
Your response must be concise. 898.41. What is the difference between the highest and the second highest Emissions(kt) of Sierra Leone?
Offer a terse response. 14.67. What is the difference between the highest and the lowest Emissions(kt) in Middle East & North Africa (developing only)?
Provide a short and direct response. 6.69e+04. What is the difference between the highest and the lowest Emissions(kt) of Burkina Faso?
Make the answer very short. 128.34. What is the difference between the highest and the lowest Emissions(kt) in Peru?
Your answer should be very brief. 5724.19. What is the difference between the highest and the lowest Emissions(kt) of Sierra Leone?
Provide a succinct answer. 231.02. 